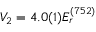Convert formula to latex. <formula><loc_0><loc_0><loc_500><loc_500>V _ { 2 } = 4 . 0 ( 1 ) E _ { r } ^ { ( 7 5 2 ) }</formula> 